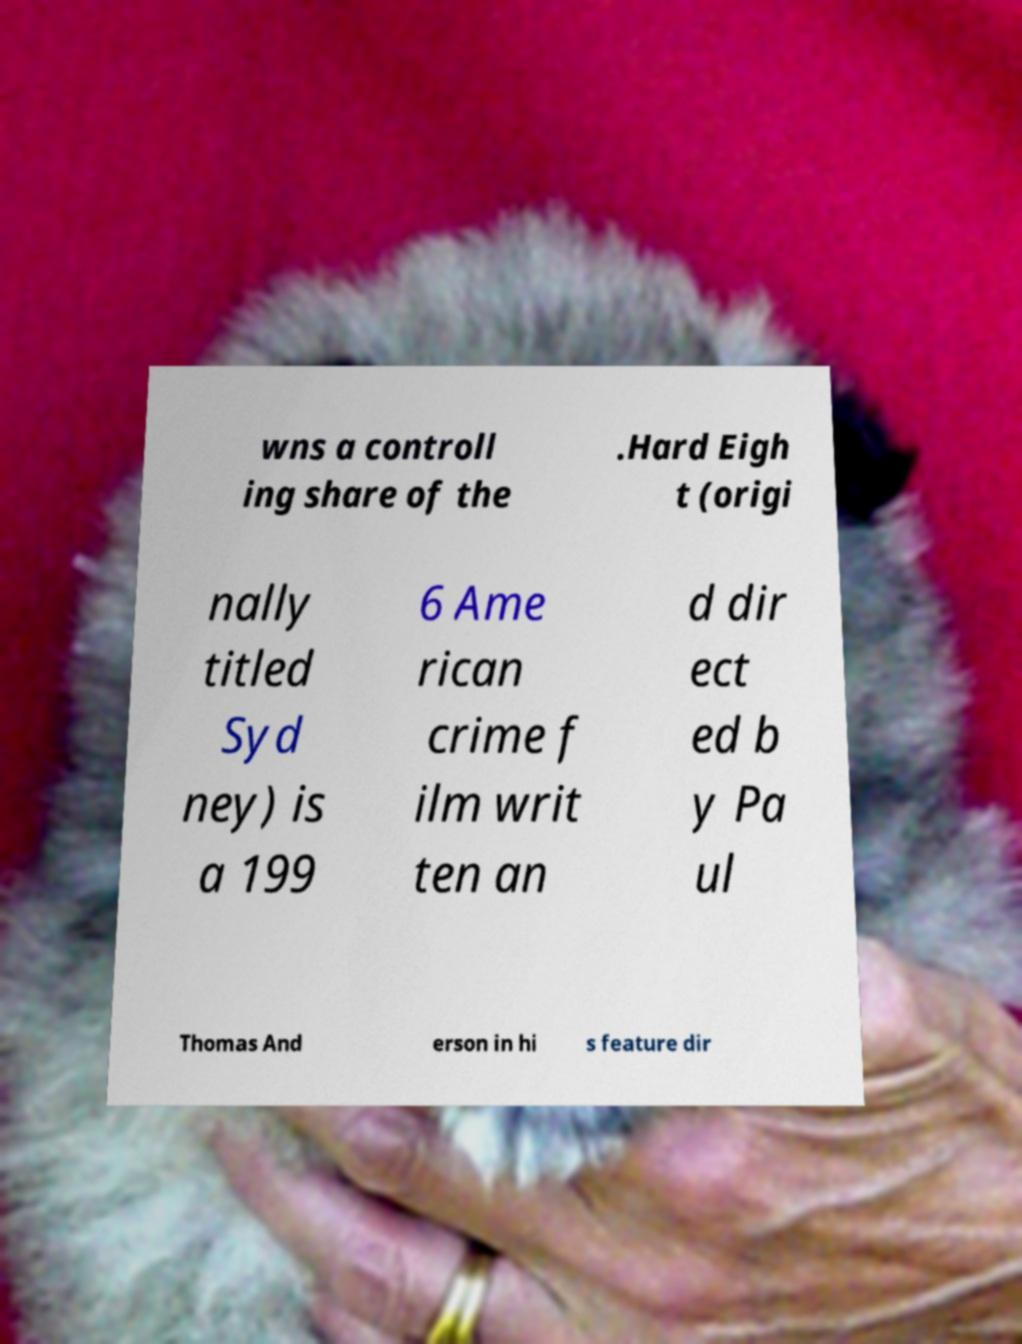What messages or text are displayed in this image? I need them in a readable, typed format. wns a controll ing share of the .Hard Eigh t (origi nally titled Syd ney) is a 199 6 Ame rican crime f ilm writ ten an d dir ect ed b y Pa ul Thomas And erson in hi s feature dir 